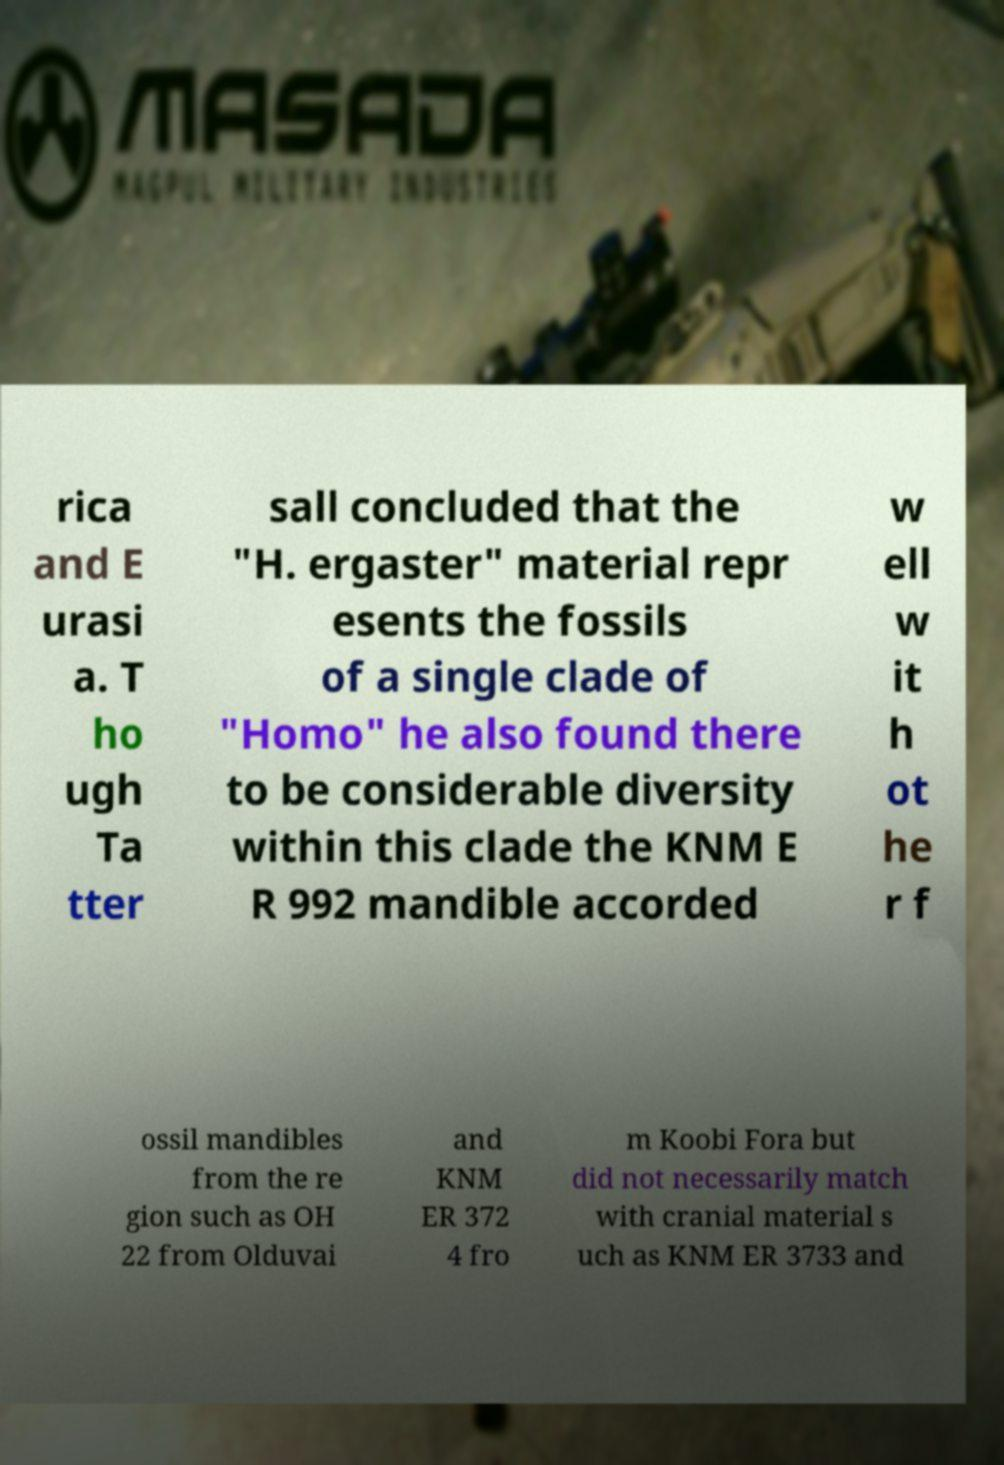Please read and relay the text visible in this image. What does it say? rica and E urasi a. T ho ugh Ta tter sall concluded that the "H. ergaster" material repr esents the fossils of a single clade of "Homo" he also found there to be considerable diversity within this clade the KNM E R 992 mandible accorded w ell w it h ot he r f ossil mandibles from the re gion such as OH 22 from Olduvai and KNM ER 372 4 fro m Koobi Fora but did not necessarily match with cranial material s uch as KNM ER 3733 and 